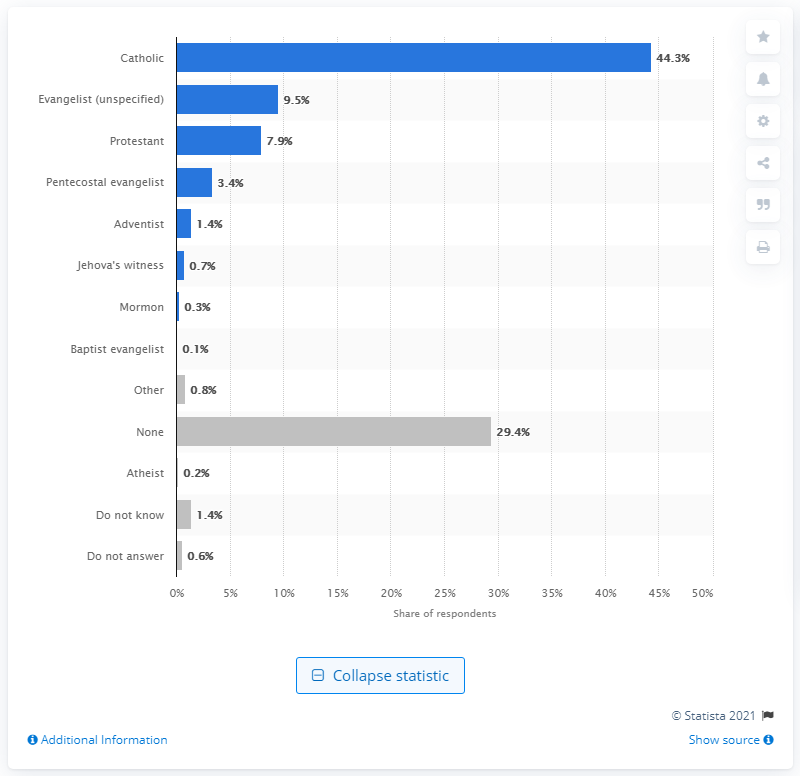Mention a couple of crucial points in this snapshot. A recent survey conducted in the Dominican Republic revealed that only 0.2% of the population self-identified as atheist. 